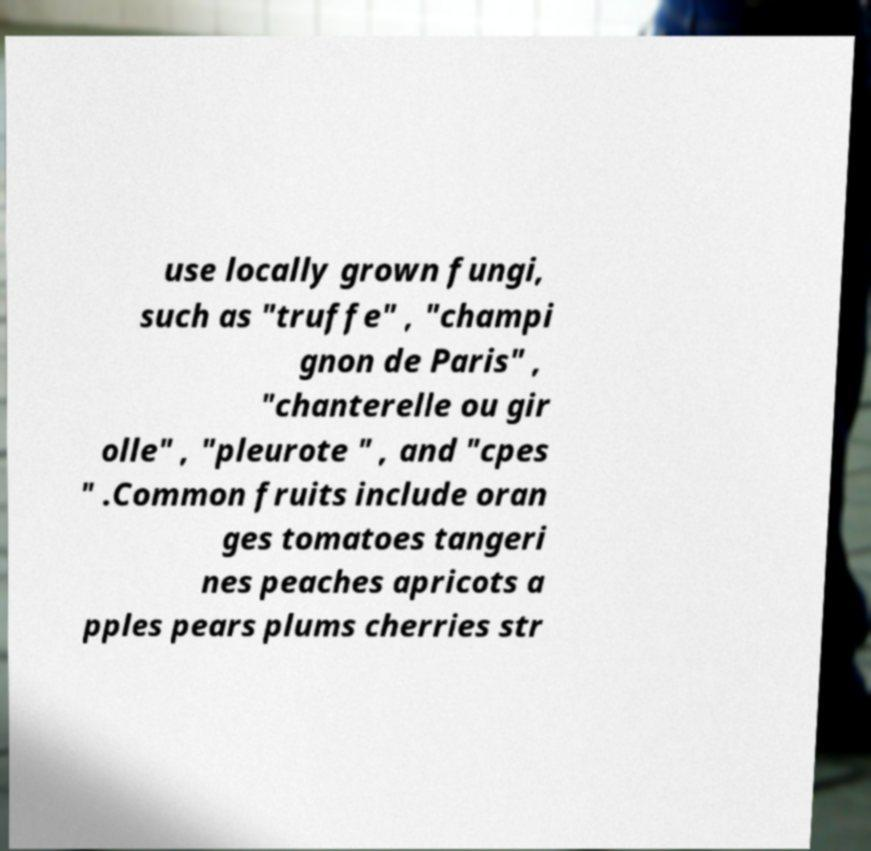Could you assist in decoding the text presented in this image and type it out clearly? use locally grown fungi, such as "truffe" , "champi gnon de Paris" , "chanterelle ou gir olle" , "pleurote " , and "cpes " .Common fruits include oran ges tomatoes tangeri nes peaches apricots a pples pears plums cherries str 